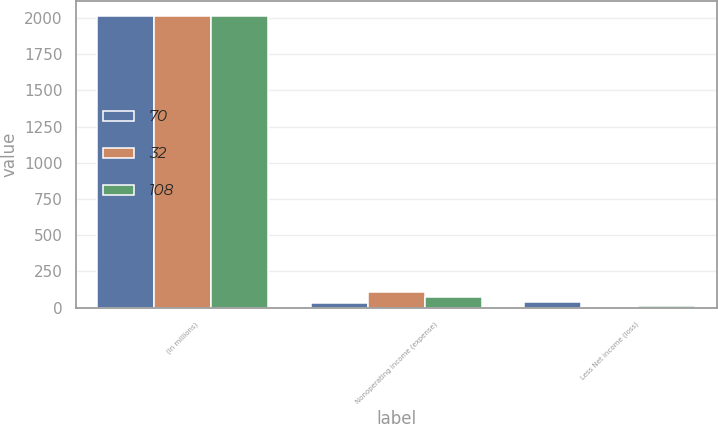Convert chart to OTSL. <chart><loc_0><loc_0><loc_500><loc_500><stacked_bar_chart><ecel><fcel>(in millions)<fcel>Nonoperating income (expense)<fcel>Less Net income (loss)<nl><fcel>70<fcel>2017<fcel>32<fcel>37<nl><fcel>32<fcel>2016<fcel>108<fcel>2<nl><fcel>108<fcel>2015<fcel>70<fcel>7<nl></chart> 